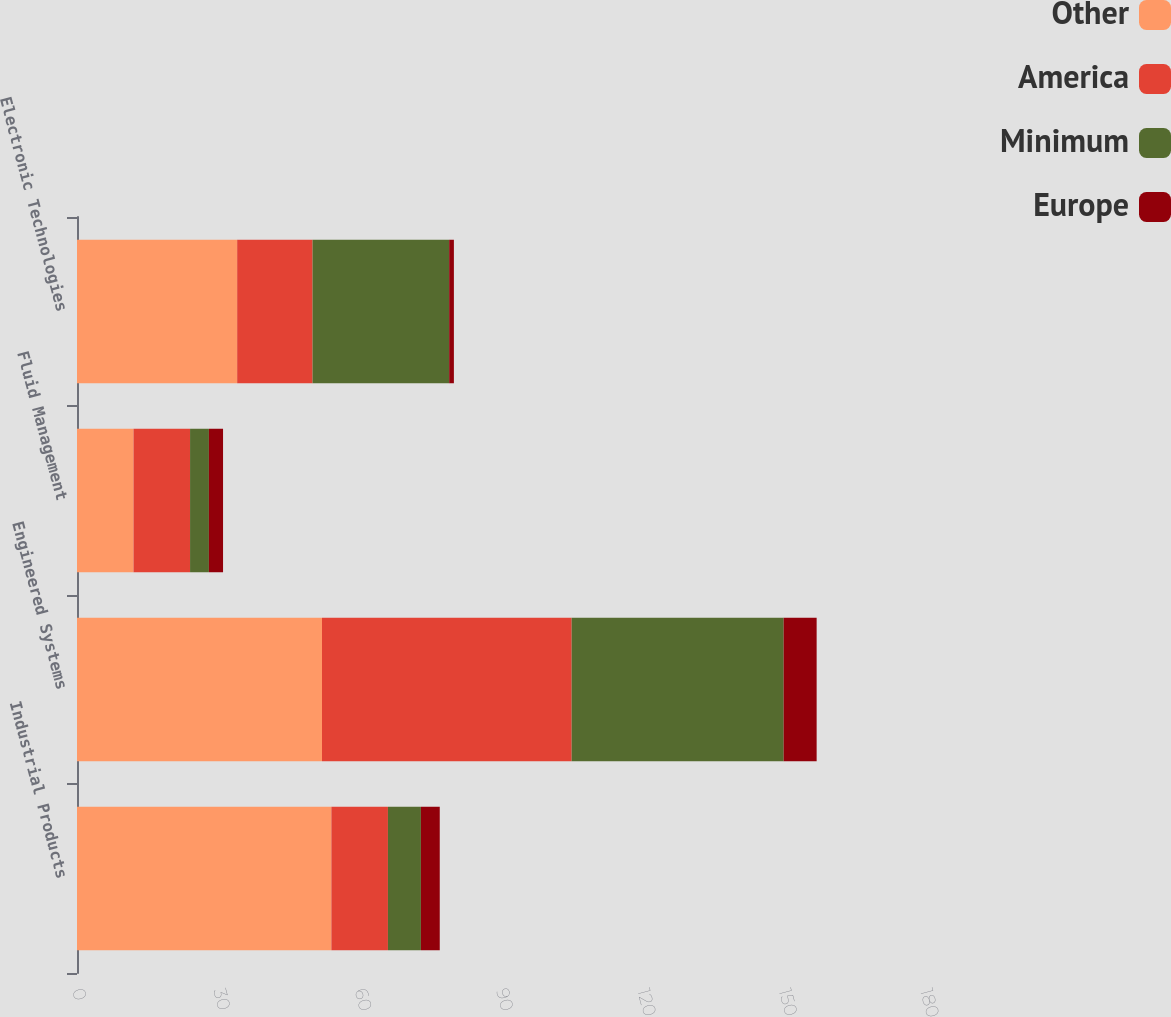<chart> <loc_0><loc_0><loc_500><loc_500><stacked_bar_chart><ecel><fcel>Industrial Products<fcel>Engineered Systems<fcel>Fluid Management<fcel>Electronic Technologies<nl><fcel>Other<fcel>54<fcel>52<fcel>12<fcel>34<nl><fcel>America<fcel>12<fcel>53<fcel>12<fcel>16<nl><fcel>Minimum<fcel>7<fcel>45<fcel>4<fcel>29<nl><fcel>Europe<fcel>4<fcel>7<fcel>3<fcel>1<nl></chart> 